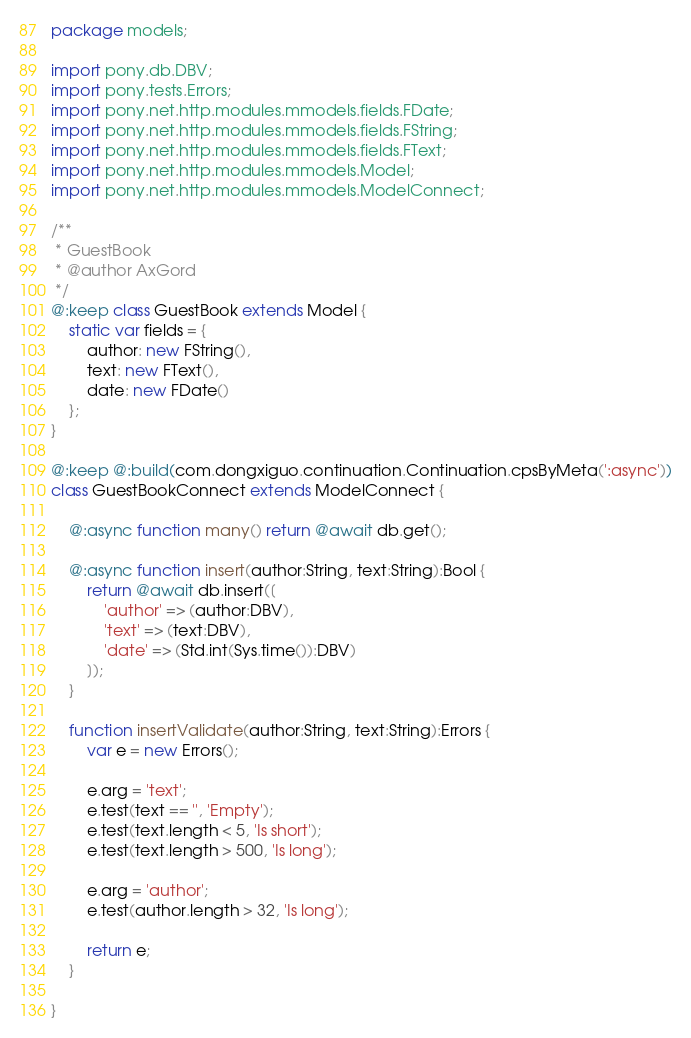<code> <loc_0><loc_0><loc_500><loc_500><_Haxe_>package models;

import pony.db.DBV;
import pony.tests.Errors;
import pony.net.http.modules.mmodels.fields.FDate;
import pony.net.http.modules.mmodels.fields.FString;
import pony.net.http.modules.mmodels.fields.FText;
import pony.net.http.modules.mmodels.Model;
import pony.net.http.modules.mmodels.ModelConnect;

/**
 * GuestBook
 * @author AxGord
 */
@:keep class GuestBook extends Model {
	static var fields = {
		author: new FString(),
		text: new FText(),
		date: new FDate()
	};
}

@:keep @:build(com.dongxiguo.continuation.Continuation.cpsByMeta(':async'))
class GuestBookConnect extends ModelConnect {
	
	@:async function many() return @await db.get();
	
	@:async function insert(author:String, text:String):Bool {
		return @await db.insert([
			'author' => (author:DBV),
			'text' => (text:DBV),
			'date' => (Std.int(Sys.time()):DBV)
		]);
	}
	
	function insertValidate(author:String, text:String):Errors {
		var e = new Errors();
		
		e.arg = 'text';
		e.test(text == '', 'Empty');
		e.test(text.length < 5, 'Is short');
		e.test(text.length > 500, 'Is long');
		
		e.arg = 'author';
		e.test(author.length > 32, 'Is long');
		
		return e;
	}
	
}</code> 